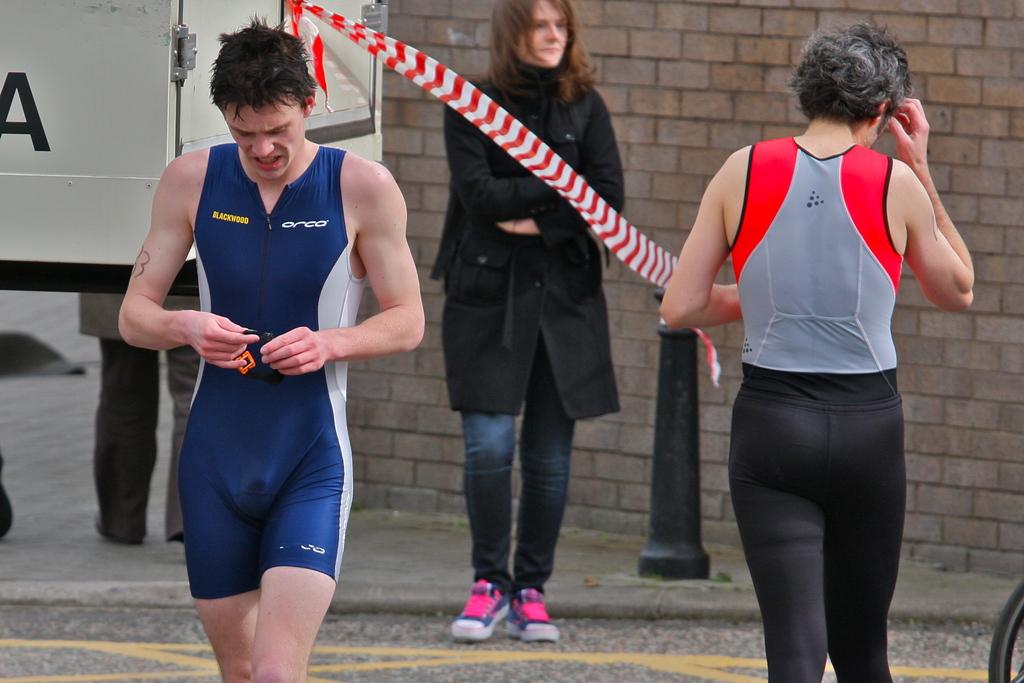What is the brand of athletic gear on the person to the left?
Make the answer very short. Area. What name is on the top right of the person on the left?
Your answer should be very brief. Orca. 